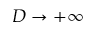<formula> <loc_0><loc_0><loc_500><loc_500>D \to + \infty</formula> 